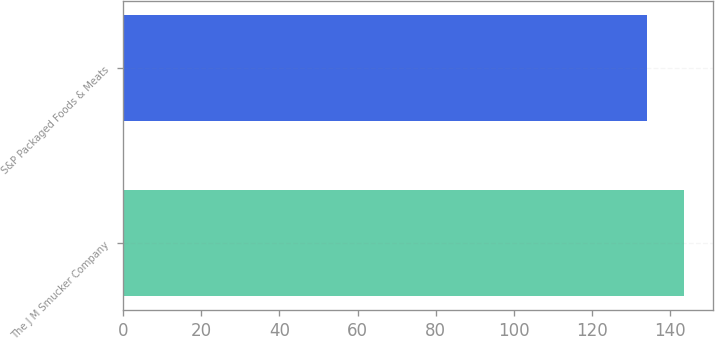Convert chart. <chart><loc_0><loc_0><loc_500><loc_500><bar_chart><fcel>The J M Smucker Company<fcel>S&P Packaged Foods & Meats<nl><fcel>143.66<fcel>134.16<nl></chart> 